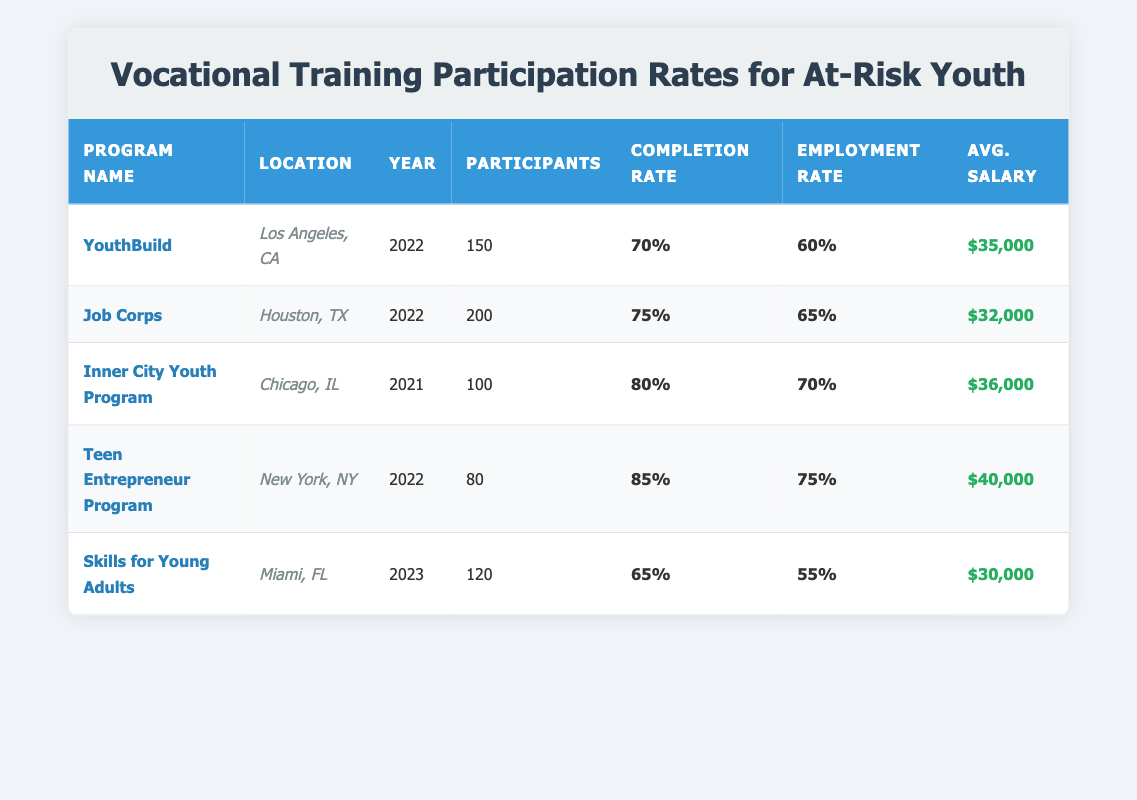What is the completion rate for the Teen Entrepreneur Program? The completion rate for the Teen Entrepreneur Program listed in the table is specifically noted as 85%.
Answer: 85% Which program has the highest employment rate post-training? The employment rates post-training for each program are: YouthBuild 60%, Job Corps 65%, Inner City Youth Program 70%, Teen Entrepreneur Program 75%, and Skills for Young Adults 55%. The highest among these is 75% from the Teen Entrepreneur Program.
Answer: Teen Entrepreneur Program What is the average salary post-training for participants in the Skills for Young Adults program? The Skills for Young Adults program has an average salary post-training of $30,000 as listed in the table.
Answer: $30,000 How many total participants were enrolled in all programs in the year 2022? The total participants in 2022 are: YouthBuild 150, Job Corps 200, and Teen Entrepreneur Program 80. Adding these values gives 150 + 200 + 80 = 430 participants in total for the year 2022.
Answer: 430 Is the completion rate for the Inner City Youth Program over 75%? The completion rate for the Inner City Youth Program is listed as 80%, which is indeed over 75%.
Answer: Yes What is the difference in average salary post-training between the highest and lowest program? The highest average salary is from the Teen Entrepreneur Program at $40,000, and the lowest is from the Skills for Young Adults at $30,000. The difference is $40,000 - $30,000 = $10,000.
Answer: $10,000 List the locations of programs that have a completion rate of 80% or higher. The programs with completion rates of 80% or higher are Inner City Youth Program at 80% and Teen Entrepreneur Program at 85%. Their locations are Chicago, IL and New York, NY respectively.
Answer: Chicago, IL and New York, NY Which program had more participants, YouthBuild or Job Corps? YouthBuild had 150 participants and Job Corps had 200 participants, so Job Corps had more.
Answer: Job Corps What was the average employment rate post-training for the programs listed? The employment rates are: YouthBuild 60%, Job Corps 65%, Inner City Youth Program 70%, Teen Entrepreneur Program 75%, and Skills for Young Adults 55%. Summing these gives 60 + 65 + 70 + 75 + 55 = 325, and dividing by 5 makes the average 325 / 5 = 65%.
Answer: 65% 